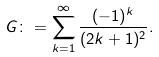<formula> <loc_0><loc_0><loc_500><loc_500>G \colon = \sum _ { k = 1 } ^ { \infty } \frac { ( - 1 ) ^ { k } } { ( 2 k + 1 ) ^ { 2 } } .</formula> 